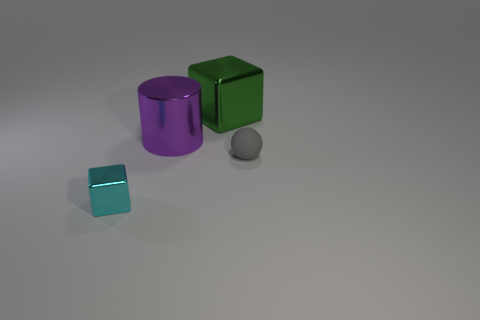Add 1 matte spheres. How many objects exist? 5 Subtract all cyan blocks. How many blocks are left? 1 Subtract all balls. How many objects are left? 3 Subtract all tiny metal blocks. Subtract all big green shiny blocks. How many objects are left? 2 Add 4 small rubber balls. How many small rubber balls are left? 5 Add 1 green blocks. How many green blocks exist? 2 Subtract 1 green cubes. How many objects are left? 3 Subtract all green cylinders. Subtract all cyan blocks. How many cylinders are left? 1 